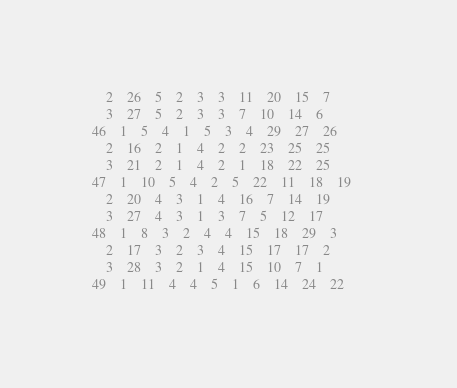Convert code to text. <code><loc_0><loc_0><loc_500><loc_500><_ObjectiveC_>	2	26	5	2	3	3	11	20	15	7	
	3	27	5	2	3	3	7	10	14	6	
46	1	5	4	1	5	3	4	29	27	26	
	2	16	2	1	4	2	2	23	25	25	
	3	21	2	1	4	2	1	18	22	25	
47	1	10	5	4	2	5	22	11	18	19	
	2	20	4	3	1	4	16	7	14	19	
	3	27	4	3	1	3	7	5	12	17	
48	1	8	3	2	4	4	15	18	29	3	
	2	17	3	2	3	4	15	17	17	2	
	3	28	3	2	1	4	15	10	7	1	
49	1	11	4	4	5	1	6	14	24	22	</code> 